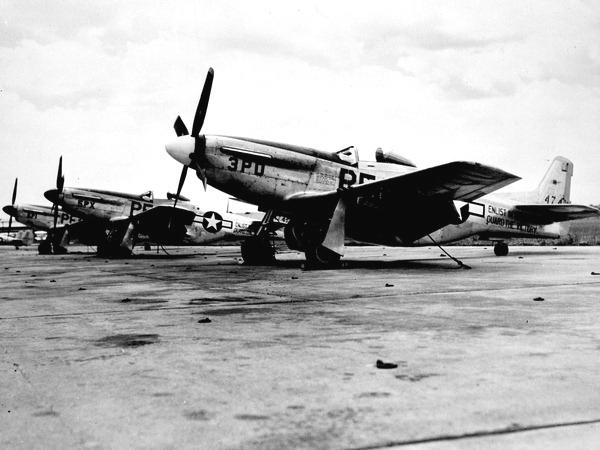Are the planes landing?
Write a very short answer. No. Are these war planes?
Concise answer only. Yes. Is this photo in color?
Short answer required. No. 